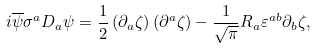Convert formula to latex. <formula><loc_0><loc_0><loc_500><loc_500>i \overline { \psi } \sigma ^ { a } D _ { a } \psi = \frac { 1 } { 2 } \left ( \partial _ { a } \zeta \right ) \left ( \partial ^ { a } \zeta \right ) - \frac { 1 } { \sqrt { \pi } } R _ { a } \varepsilon ^ { a b } \partial _ { b } \zeta ,</formula> 